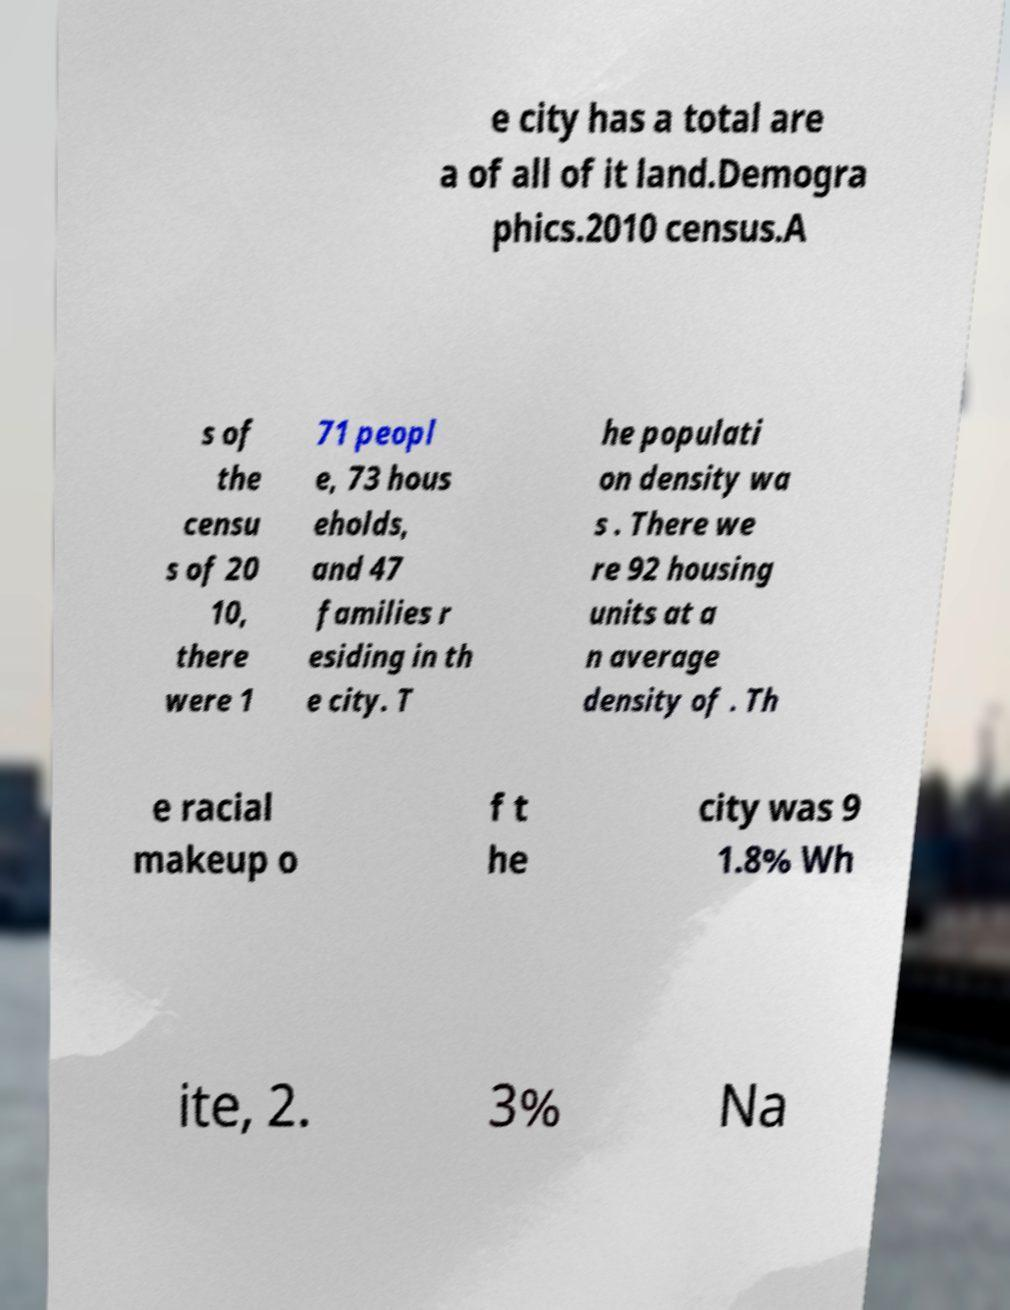What messages or text are displayed in this image? I need them in a readable, typed format. e city has a total are a of all of it land.Demogra phics.2010 census.A s of the censu s of 20 10, there were 1 71 peopl e, 73 hous eholds, and 47 families r esiding in th e city. T he populati on density wa s . There we re 92 housing units at a n average density of . Th e racial makeup o f t he city was 9 1.8% Wh ite, 2. 3% Na 